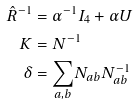<formula> <loc_0><loc_0><loc_500><loc_500>\hat { R } ^ { - 1 } & = \alpha ^ { - 1 } I _ { 4 } + \alpha U \\ K & = N ^ { - 1 } \\ \delta & = \underset { a , b } { \sum } N _ { a b } N _ { a b } ^ { - 1 }</formula> 